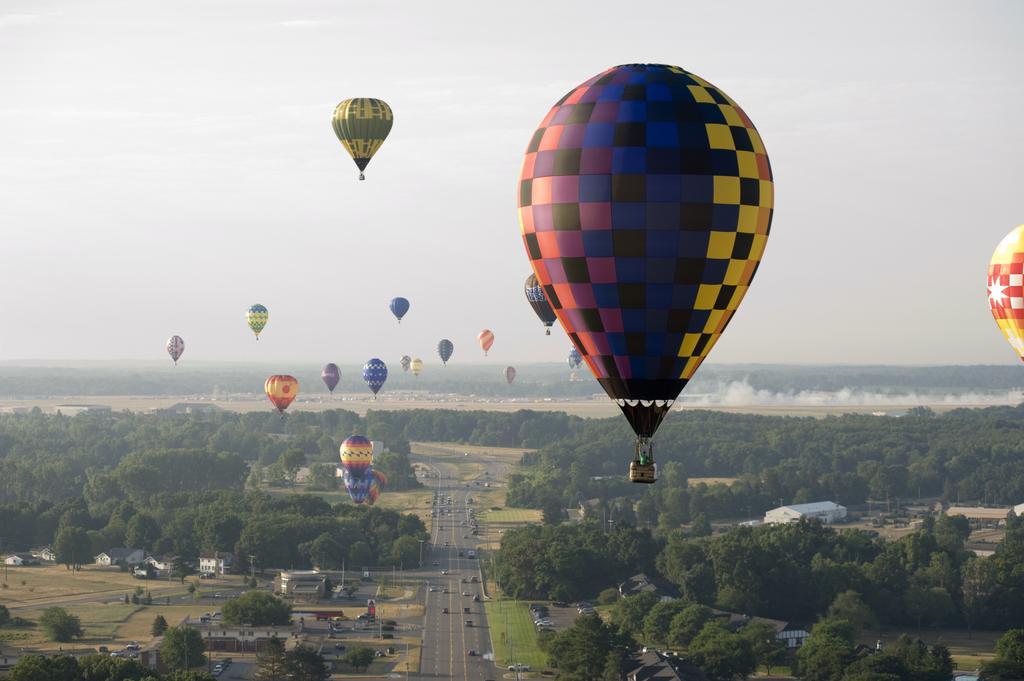Please provide a concise description of this image. In this image we can see many hot air balloons. At the bottom there is road. On the road there are many vehicles. Also there are many buildings, trees. In the background there is sky. 